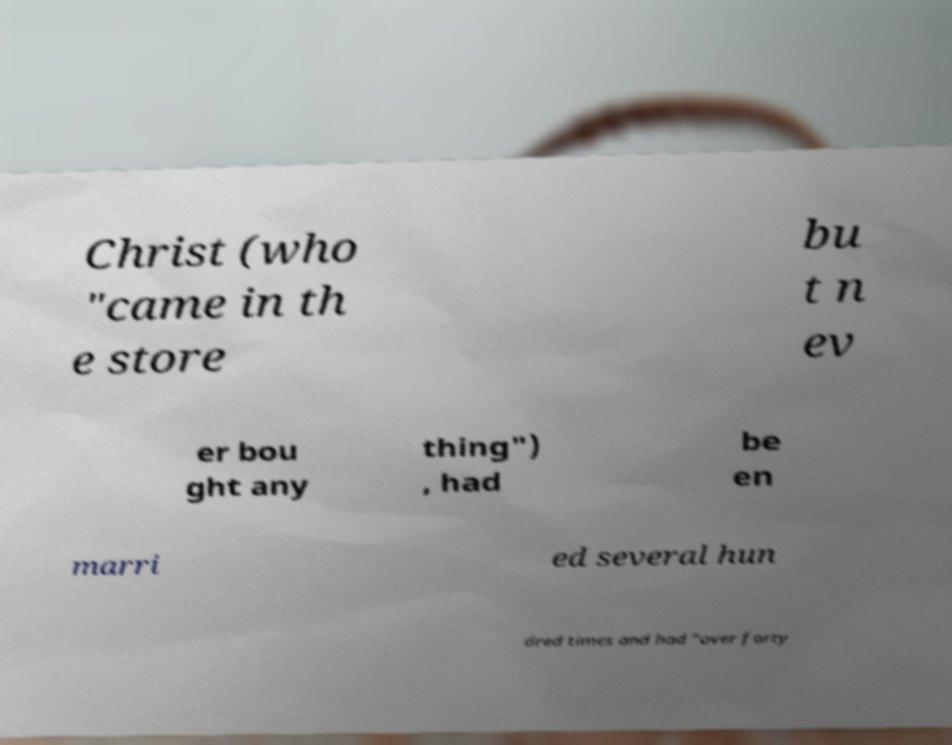What messages or text are displayed in this image? I need them in a readable, typed format. Christ (who "came in th e store bu t n ev er bou ght any thing") , had be en marri ed several hun dred times and had "over forty 